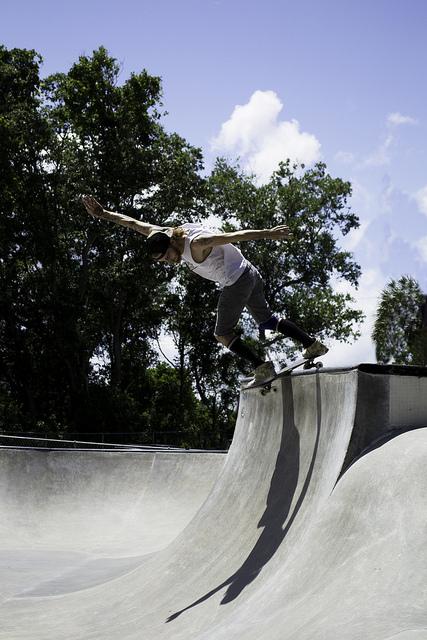What is his head protection?
Keep it brief. Helmet. Is the boy wearing a helmet?
Concise answer only. No. What is this person doing?
Write a very short answer. Skateboarding. Is this a sunny day?
Quick response, please. Yes. 